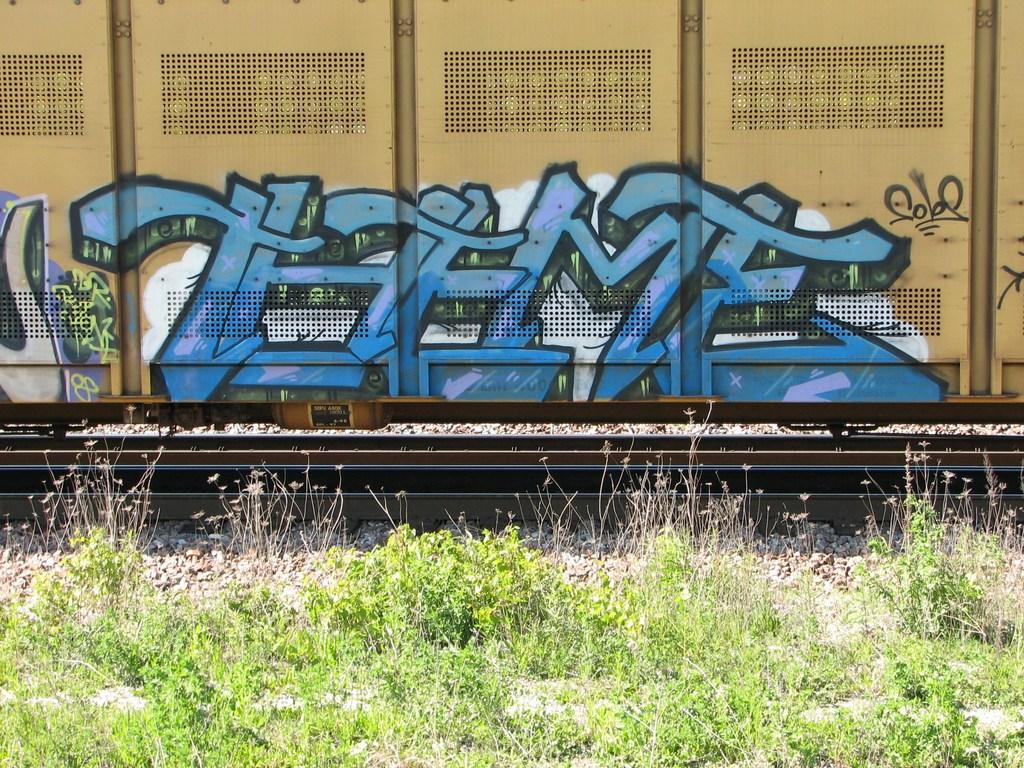Does the graffiti mean anything?
Your answer should be compact. Unanswerable. What color has been used on the graffiti?
Your response must be concise. Blue. 